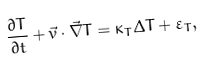Convert formula to latex. <formula><loc_0><loc_0><loc_500><loc_500>\frac { \partial T } { \partial t } + \vec { v } \cdot \vec { \nabla } T = \kappa _ { T } \Delta T + \varepsilon _ { T } ,</formula> 